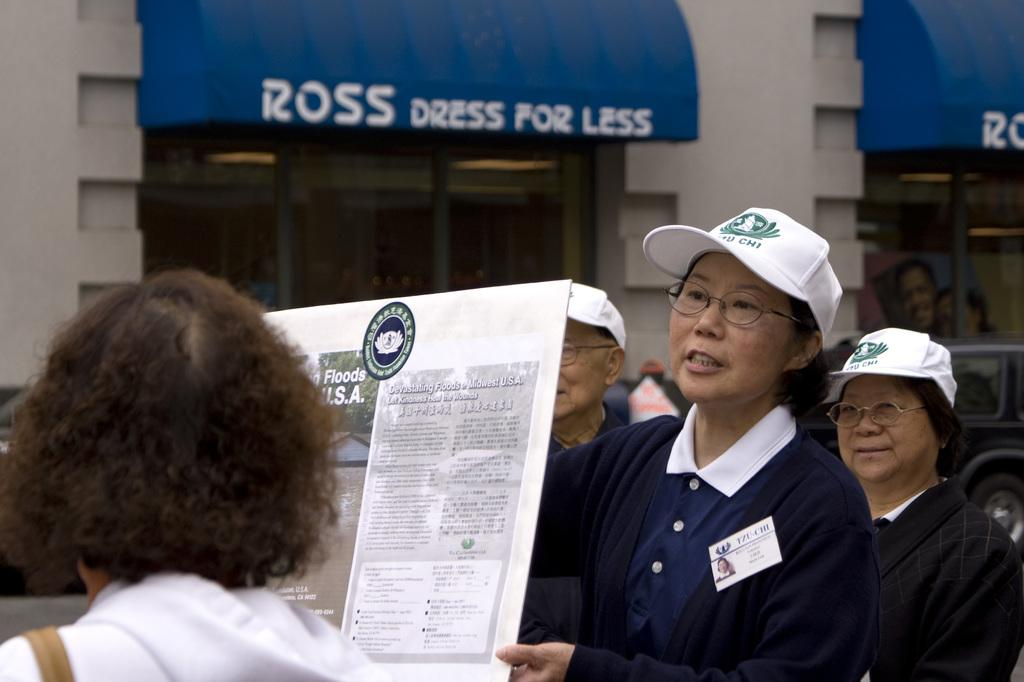What is happening in the image involving a group of people? There is a group of people standing in the image. Can you describe the person holding a board in the image? There is a person holding a board in the image. What can be seen in the background of the image? There is a vehicle and shops in the background of the image. What type of cattle can be seen grazing in the fog in the image? There is no cattle or fog present in the image. What is the condition of the roof in the image? There is no mention of a roof in the image. 